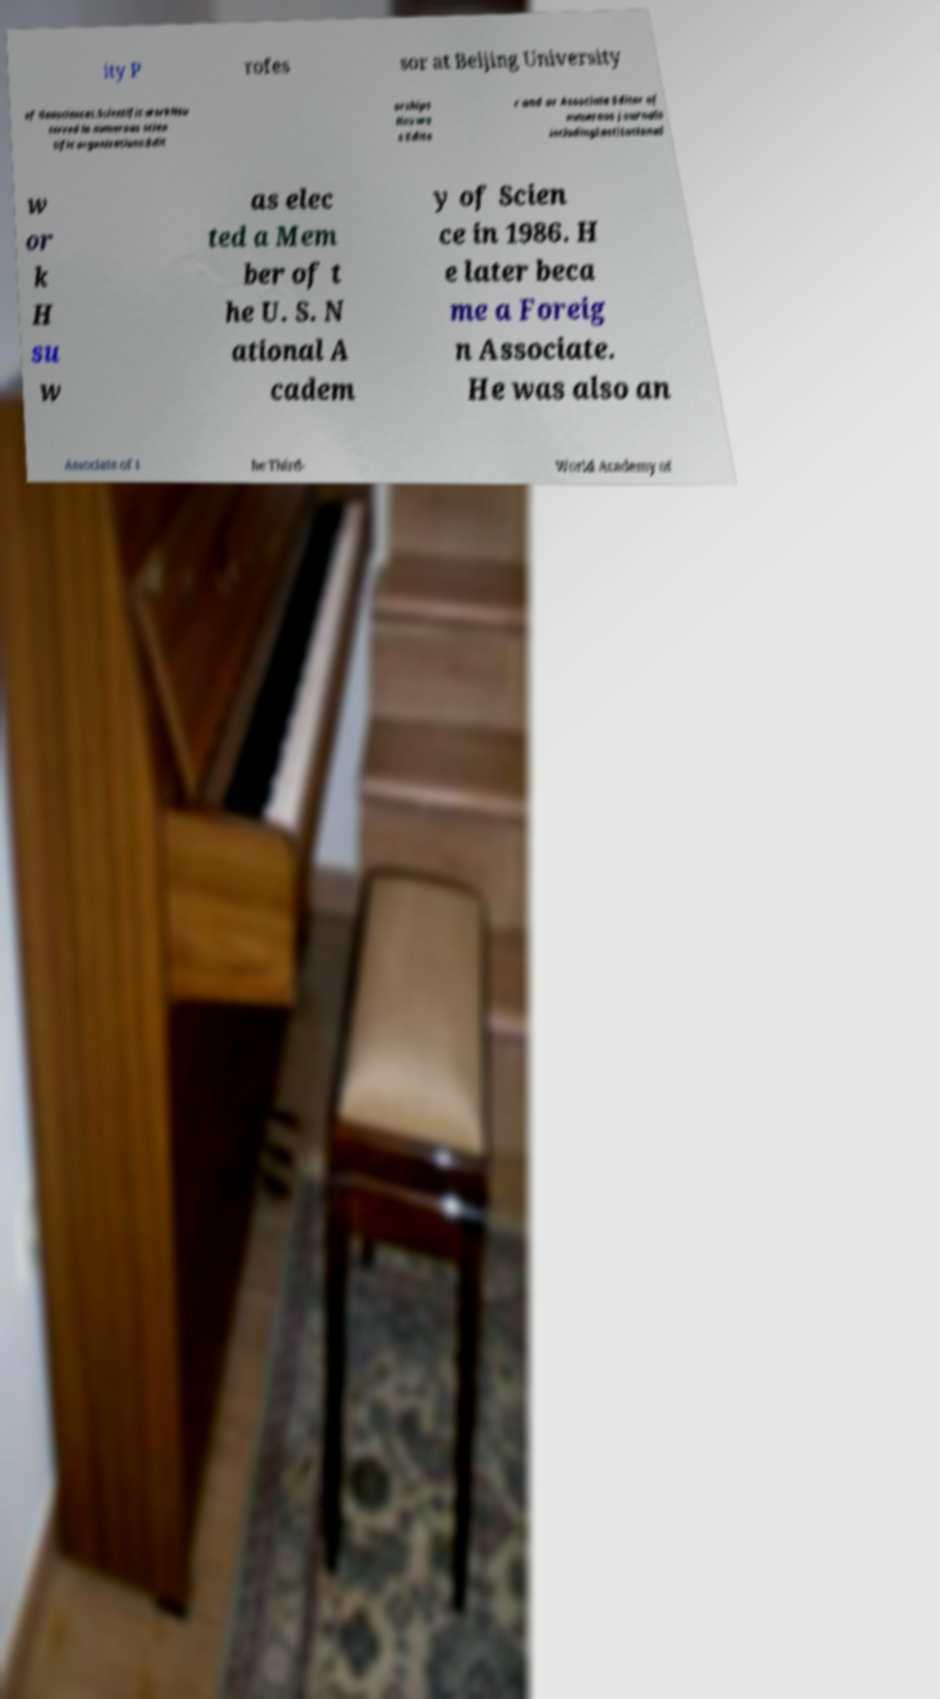Please identify and transcribe the text found in this image. ity P rofes sor at Beijing University of Geosciences.Scientific workHsu served in numerous scien tific organizations:Edit orships Hsu wa s Edito r and or Associate Editor of numerous journals includingInstitutional w or k H su w as elec ted a Mem ber of t he U. S. N ational A cadem y of Scien ce in 1986. H e later beca me a Foreig n Associate. He was also an Associate of t he Third- World Academy of 